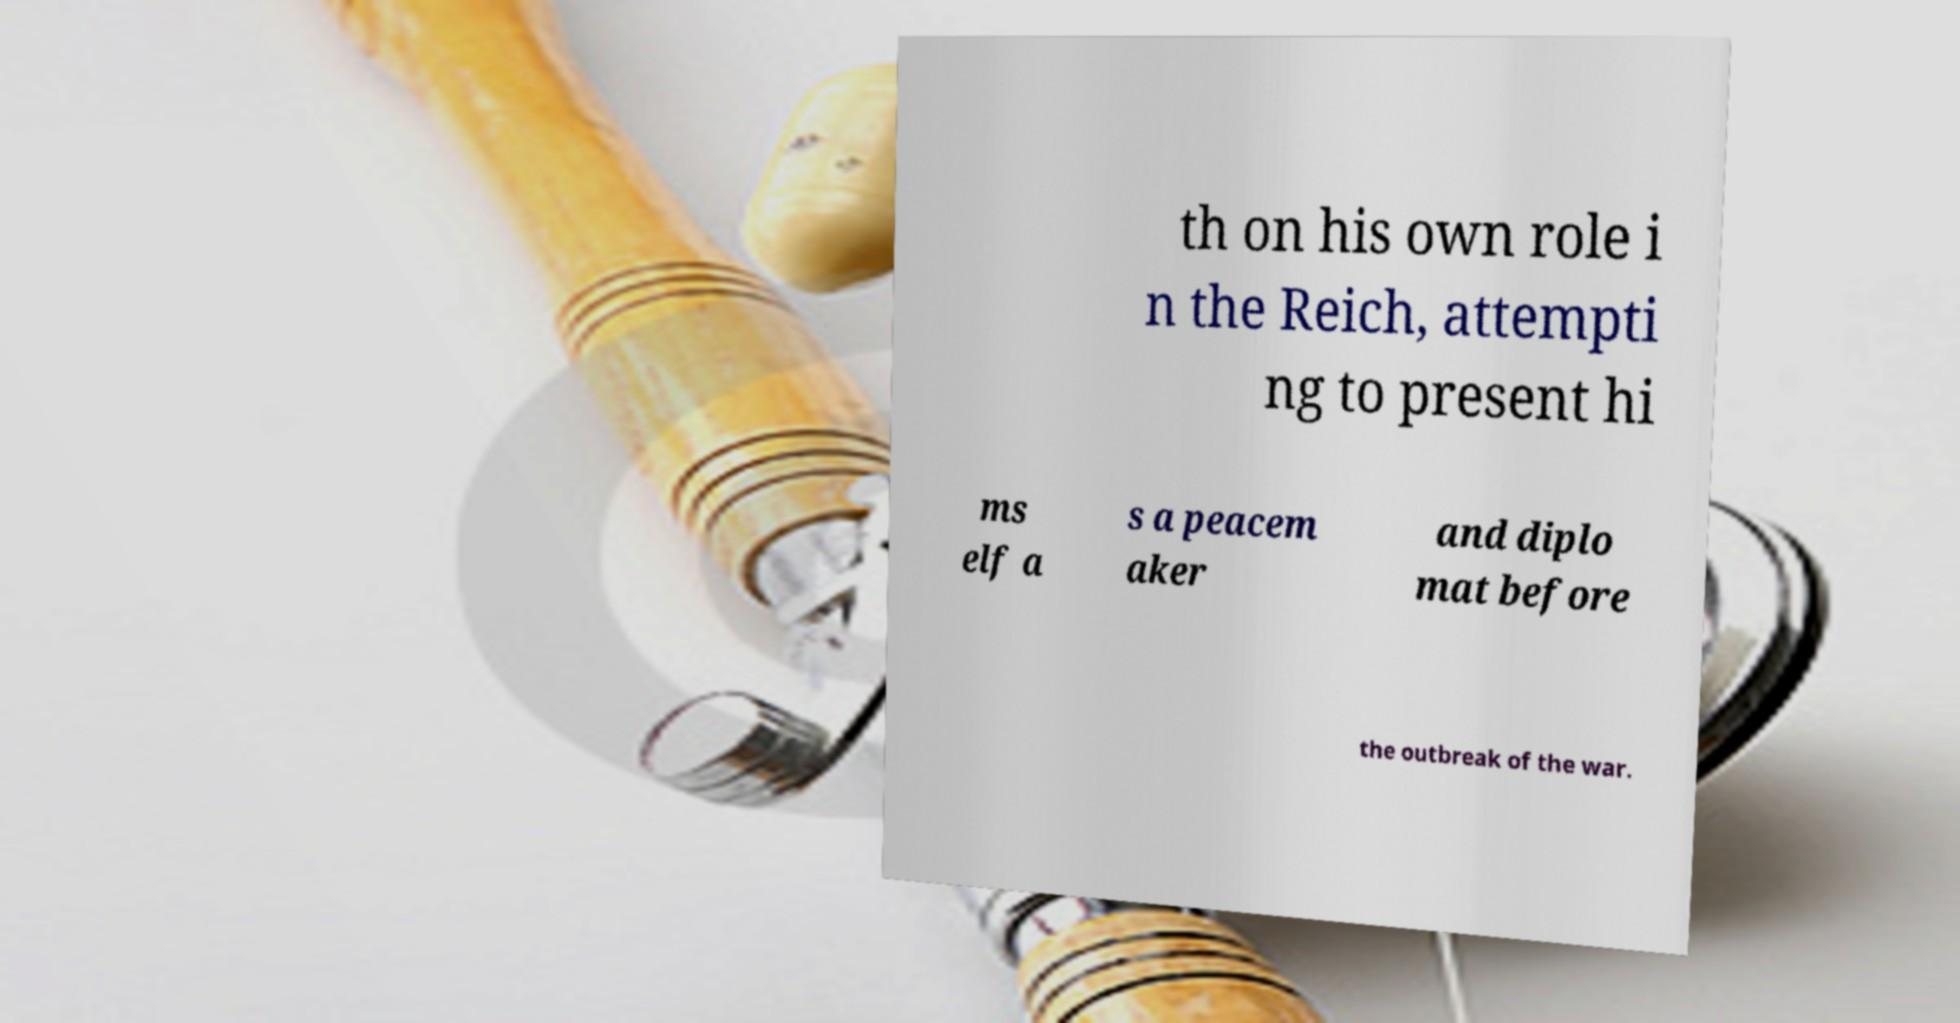For documentation purposes, I need the text within this image transcribed. Could you provide that? th on his own role i n the Reich, attempti ng to present hi ms elf a s a peacem aker and diplo mat before the outbreak of the war. 